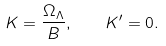<formula> <loc_0><loc_0><loc_500><loc_500>K = \frac { \Omega _ { \Lambda } } { B } , \quad K ^ { \prime } = 0 .</formula> 